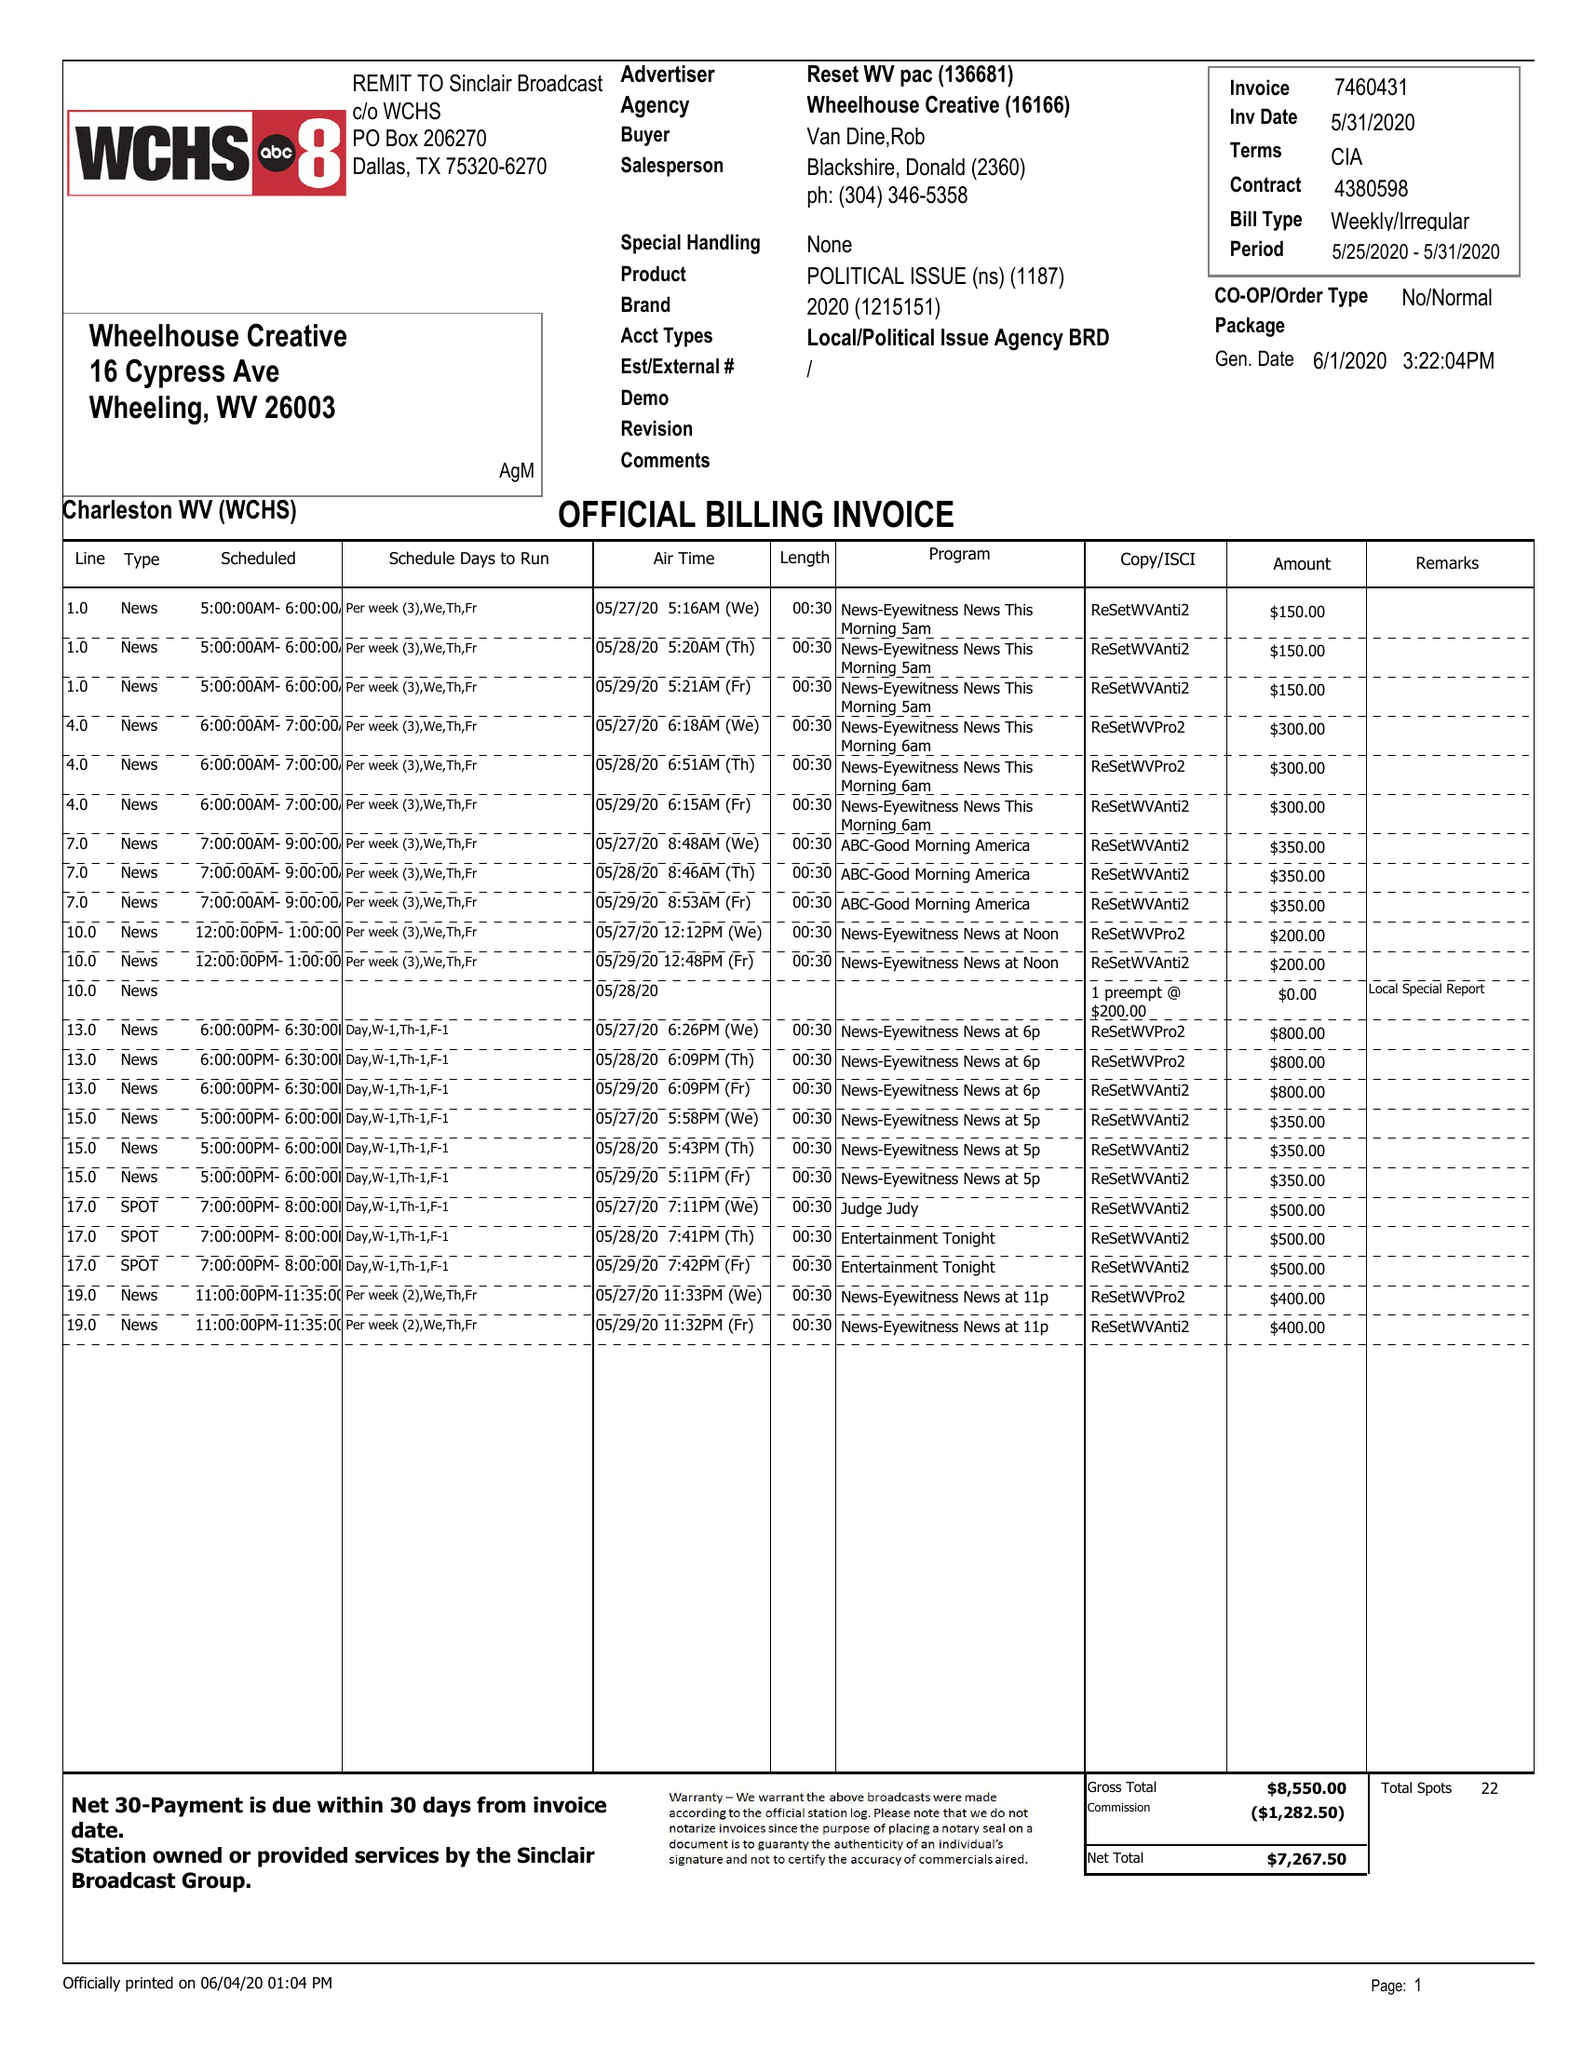What is the value for the gross_amount?
Answer the question using a single word or phrase. 8550.00 